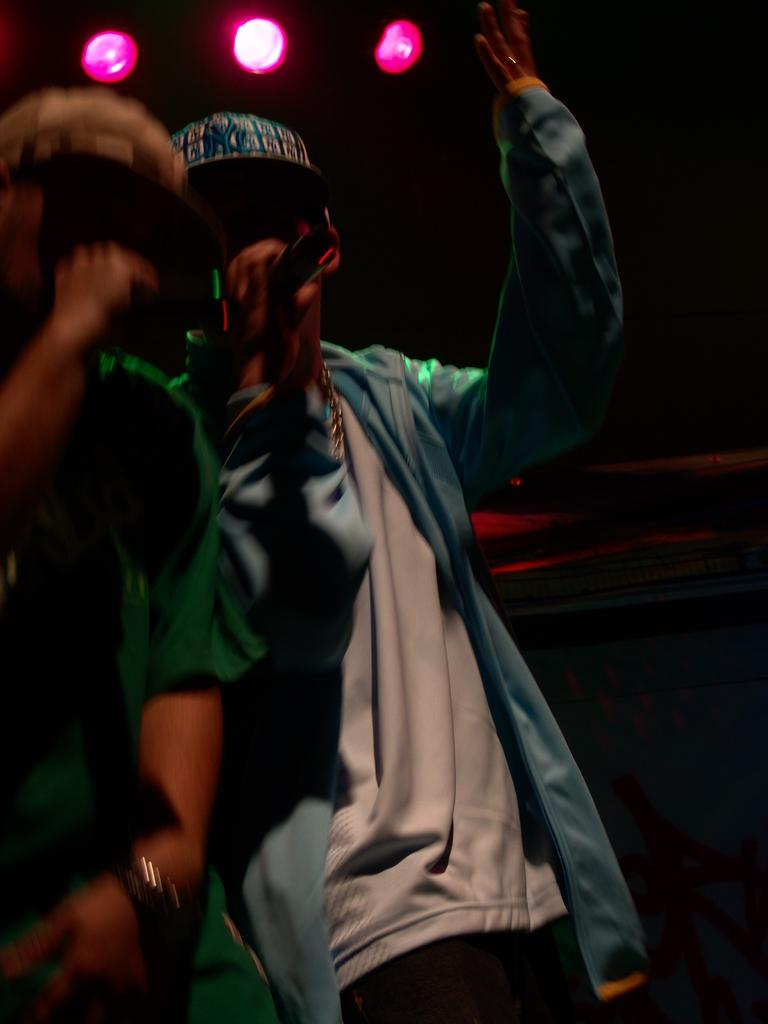How many people are in the foreground of the image? There are two persons in the foreground of the image. What are the persons holding in their hands? The persons are holding microphones in their hands. What can be seen in the background of the image? There are lights visible in the background of the image, and the background has a dark color. What might be the setting of the image? The image may have been taken on a stage. What type of toy can be seen on the floor in the image? There is no toy visible on the floor in the image. What kind of cub is present in the image? There is no cub present in the image. 